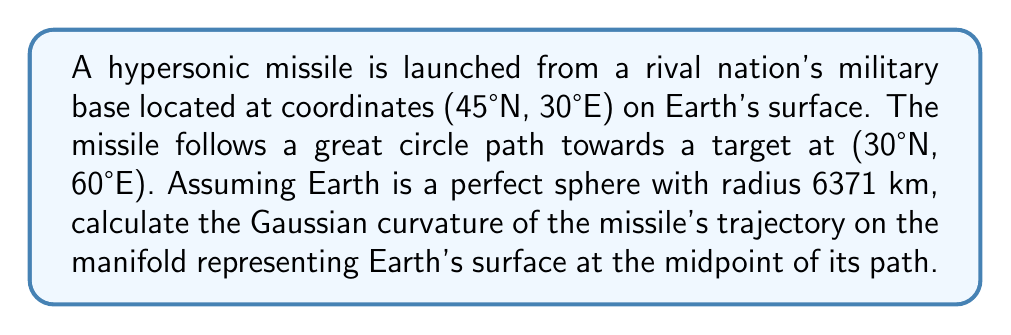What is the answer to this math problem? To solve this problem, we'll follow these steps:

1) First, we need to find the midpoint of the missile's trajectory on the great circle path.

2) Then, we'll calculate the Gaussian curvature at this point.

Step 1: Finding the midpoint

The great circle distance $d$ between two points $(φ_1, λ_1)$ and $(φ_2, λ_2)$ on a sphere is given by:

$$d = R \cdot \arccos(\sin φ_1 \sin φ_2 + \cos φ_1 \cos φ_2 \cos(λ_2 - λ_1))$$

Where $R$ is the radius of the sphere, $φ$ is latitude, and $λ$ is longitude.

The midpoint $(φ_m, λ_m)$ can be found using:

$$φ_m = \arcsin(\sin φ_1 \cos(d/2) + \cos φ_1 \sin(d/2) \cos θ)$$
$$λ_m = λ_1 + \arctan2(\sin θ \sin(d/2) \cos φ_1, \cos(d/2) - \sin φ_1 \sin φ_m)$$

Where $θ$ is the initial bearing, given by:

$$θ = \arctan2(\sin(λ_2 - λ_1) \cos φ_2, \cos φ_1 \sin φ_2 - \sin φ_1 \cos φ_2 \cos(λ_2 - λ_1))$$

Step 2: Calculating Gaussian curvature

For a sphere of radius $R$, the Gaussian curvature $K$ is constant at every point and is given by:

$$K = \frac{1}{R^2}$$

This is because a sphere has constant positive curvature everywhere on its surface.

Therefore, the Gaussian curvature of the missile's trajectory at any point, including the midpoint, is simply $1/R^2$ where $R$ is the radius of the Earth.
Answer: The Gaussian curvature of the missile's trajectory on the Earth's surface at the midpoint of its path is:

$$K = \frac{1}{R^2} = \frac{1}{(6371 \text{ km})^2} \approx 2.46 \times 10^{-14} \text{ km}^{-2}$$ 